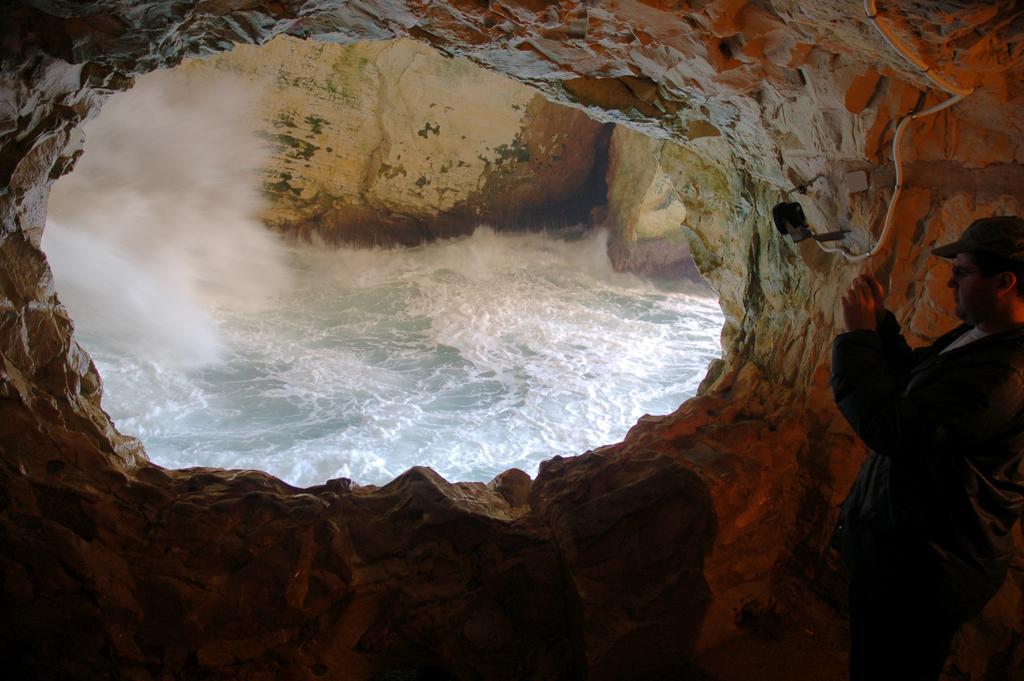Could you give a brief overview of what you see in this image? In this picture I can see the view which looks like Hanikra place and on the right side of this picture I can see a man standing and holding a thing in his hands. 